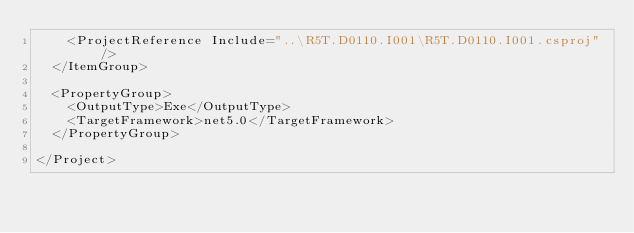<code> <loc_0><loc_0><loc_500><loc_500><_XML_>    <ProjectReference Include="..\R5T.D0110.I001\R5T.D0110.I001.csproj" />
  </ItemGroup>

  <PropertyGroup>
    <OutputType>Exe</OutputType>
    <TargetFramework>net5.0</TargetFramework>
  </PropertyGroup>

</Project>
</code> 